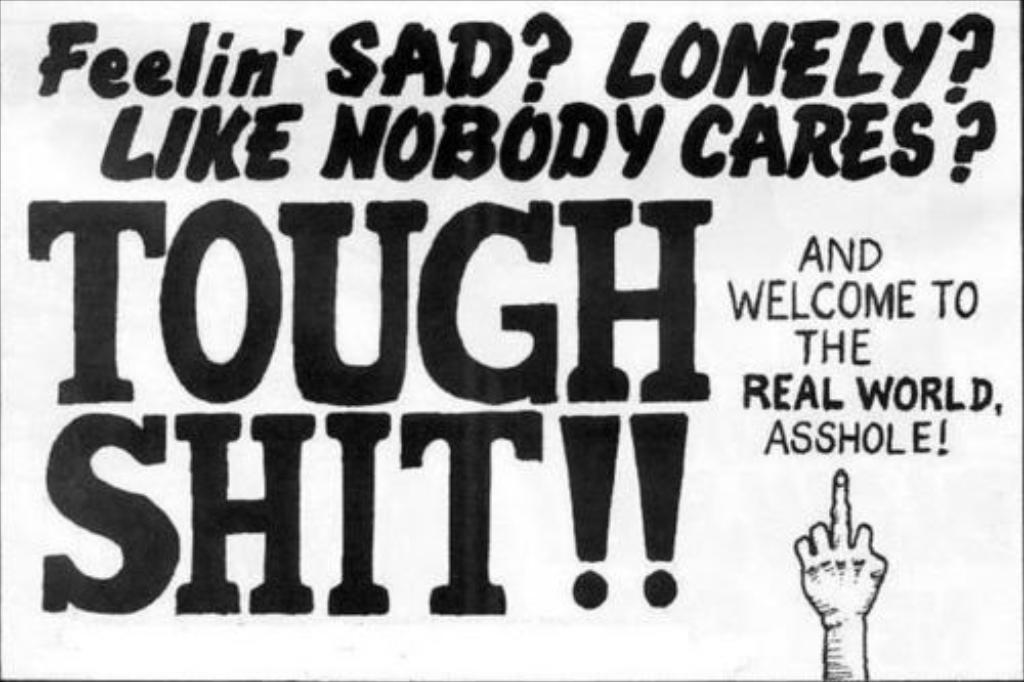Provide a one-sentence caption for the provided image. A black and white sign that says Feelin' SAD. 